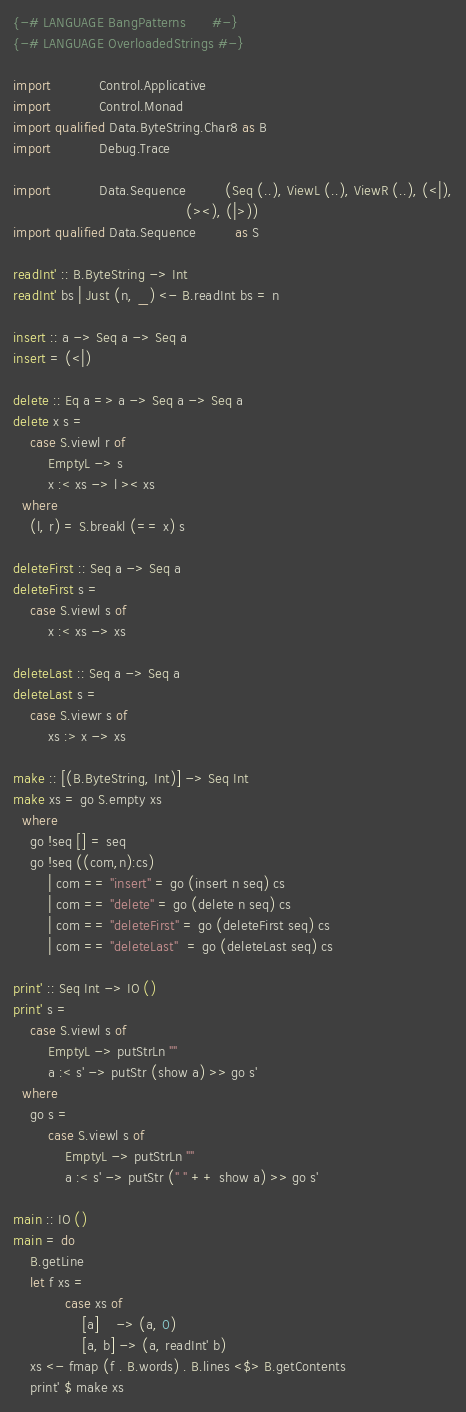<code> <loc_0><loc_0><loc_500><loc_500><_Haskell_>{-# LANGUAGE BangPatterns      #-}
{-# LANGUAGE OverloadedStrings #-}

import           Control.Applicative
import           Control.Monad
import qualified Data.ByteString.Char8 as B
import           Debug.Trace

import           Data.Sequence         (Seq (..), ViewL (..), ViewR (..), (<|),
                                        (><), (|>))
import qualified Data.Sequence         as S

readInt' :: B.ByteString -> Int
readInt' bs | Just (n, _) <- B.readInt bs = n

insert :: a -> Seq a -> Seq a
insert = (<|)

delete :: Eq a => a -> Seq a -> Seq a
delete x s =
    case S.viewl r of
        EmptyL -> s
        x :< xs -> l >< xs
  where
    (l, r) = S.breakl (== x) s

deleteFirst :: Seq a -> Seq a
deleteFirst s =
    case S.viewl s of
        x :< xs -> xs

deleteLast :: Seq a -> Seq a
deleteLast s =
    case S.viewr s of
        xs :> x -> xs

make :: [(B.ByteString, Int)] -> Seq Int
make xs = go S.empty xs
  where
    go !seq [] = seq
    go !seq ((com,n):cs)
        | com == "insert" = go (insert n seq) cs
        | com == "delete" = go (delete n seq) cs
        | com == "deleteFirst" = go (deleteFirst seq) cs
        | com == "deleteLast"  = go (deleteLast seq) cs

print' :: Seq Int -> IO ()
print' s =
    case S.viewl s of
        EmptyL -> putStrLn ""
        a :< s' -> putStr (show a) >> go s'
  where
    go s =
        case S.viewl s of
            EmptyL -> putStrLn ""
            a :< s' -> putStr (" " ++ show a) >> go s'

main :: IO ()
main = do
    B.getLine
    let f xs =
            case xs of
                [a]    -> (a, 0)
                [a, b] -> (a, readInt' b)
    xs <- fmap (f . B.words) . B.lines <$> B.getContents
    print' $ make xs

</code> 